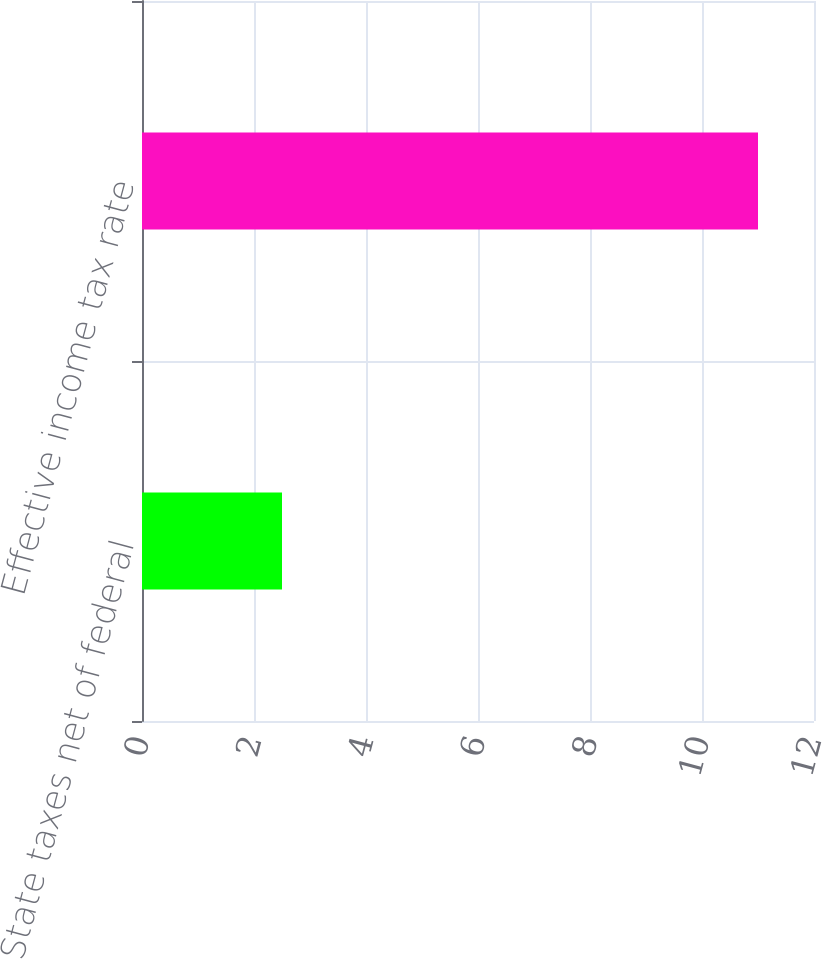Convert chart to OTSL. <chart><loc_0><loc_0><loc_500><loc_500><bar_chart><fcel>State taxes net of federal<fcel>Effective income tax rate<nl><fcel>2.5<fcel>11<nl></chart> 